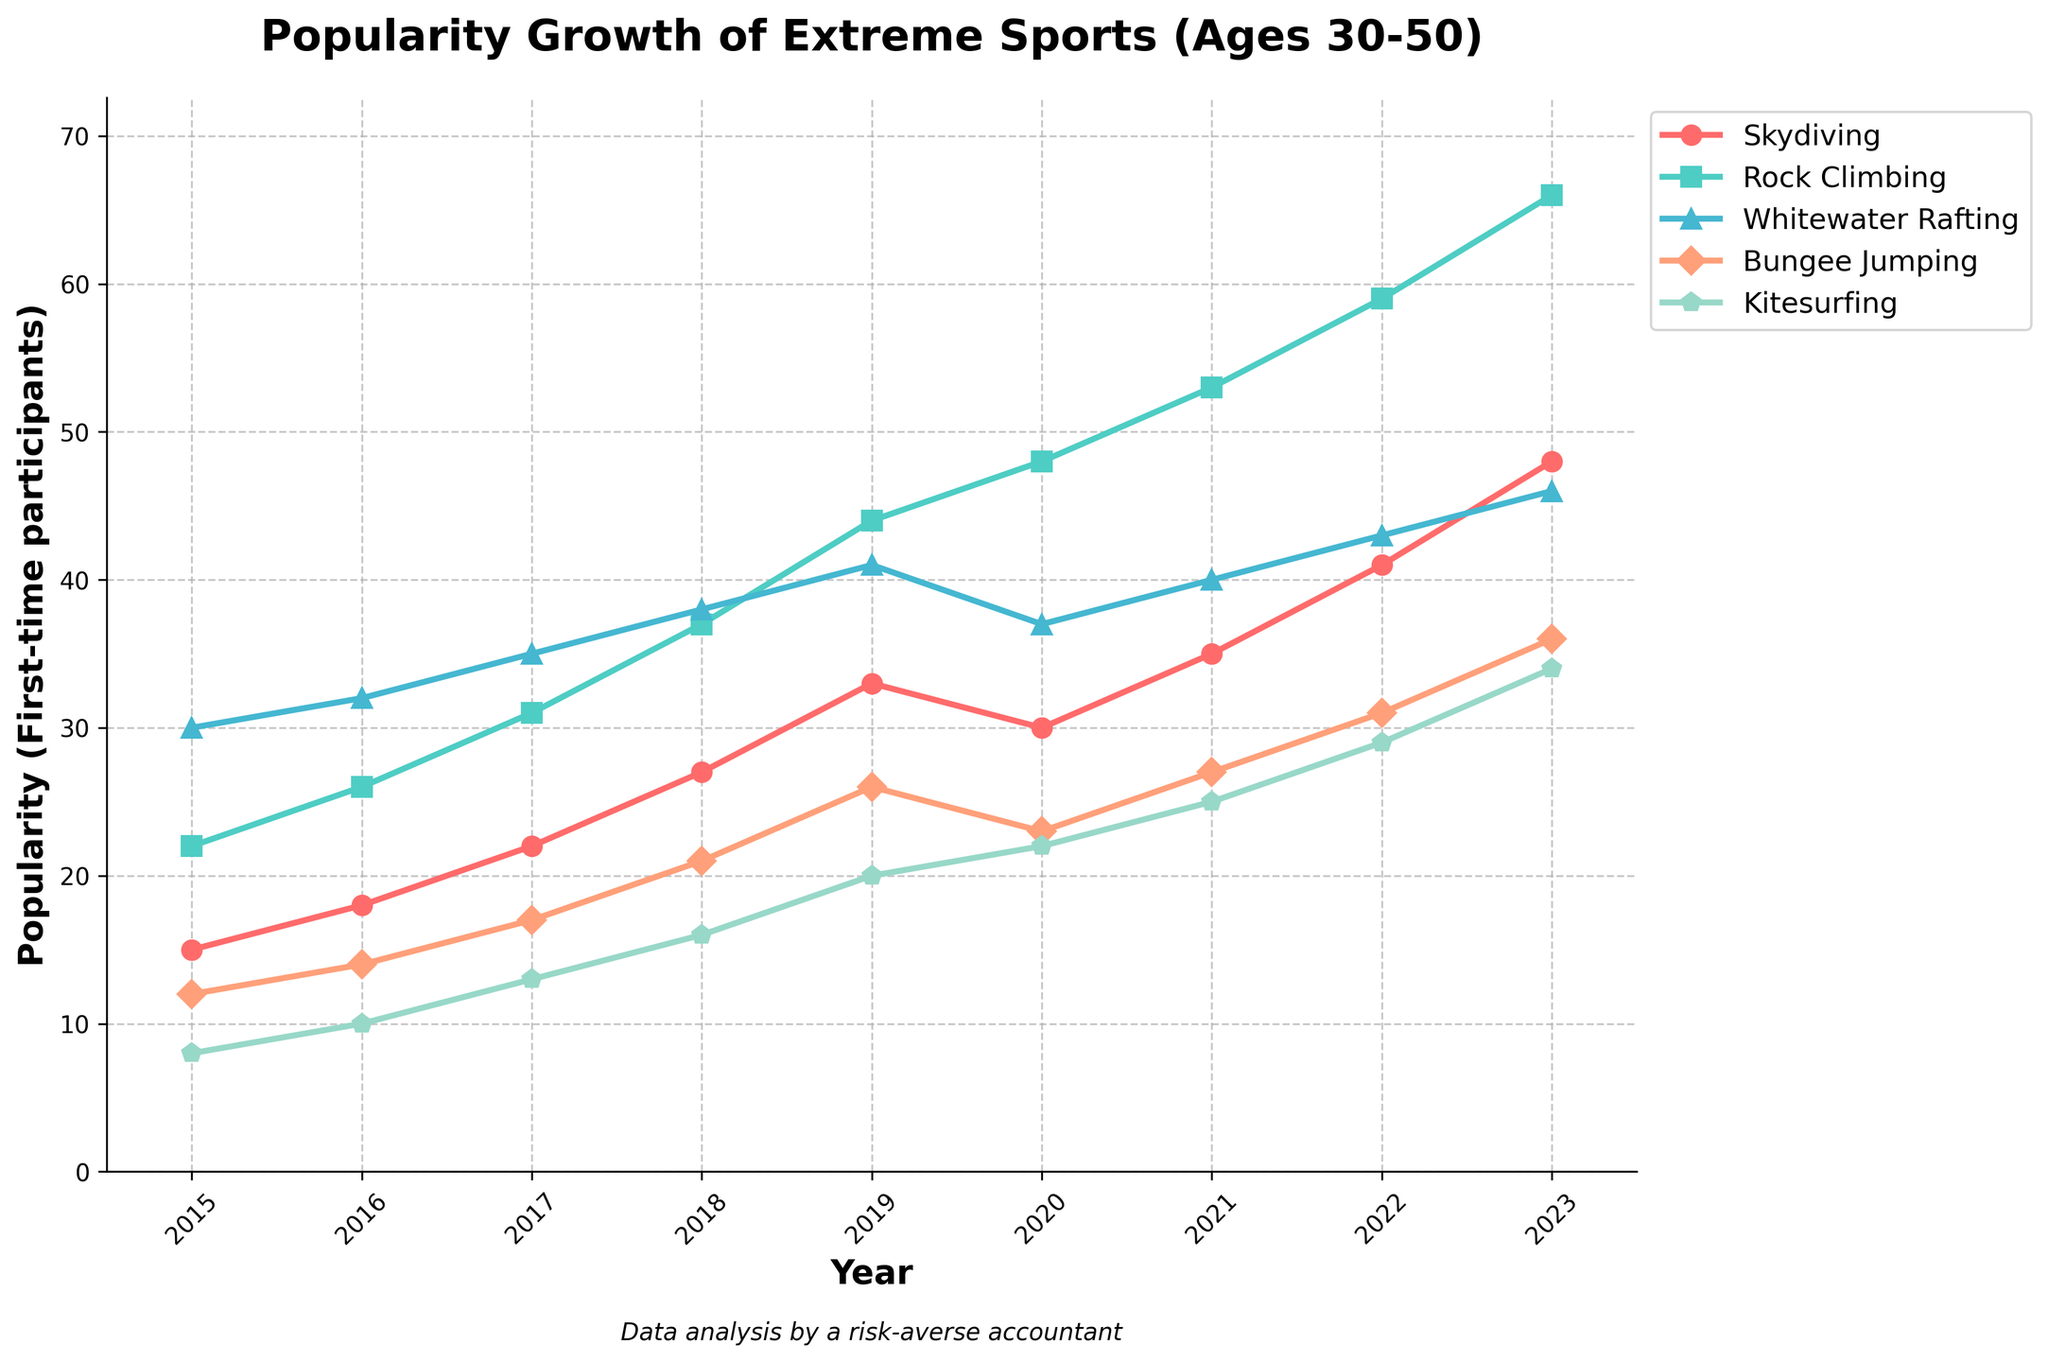What is the trend for skydiving's popularity between 2015 and 2023? The chart shows that the popularity of skydiving among first-time participants aged 30-50 increased steadily from 15 in 2015 to 48 in 2023. The values consistently rise each year.
Answer: Steadily increasing Which sport had the highest popularity in 2023? By looking at the chart, you can see that Rock Climbing has the highest number of first-time participants in 2023, reaching 66.
Answer: Rock Climbing During which year did whitewater rafting see its highest number of first-time participants? The chart indicates that the highest number of first-time participants for Whitewater Rafting is 46, which occurs in the year 2023.
Answer: 2023 Compare the popularity of bungee jumping and kitesurfing in 2019. Which one was more popular? The chart shows that in 2019, bungee jumping had 26 first-time participants while kitesurfing had 20. Thus, bungee jumping was more popular.
Answer: Bungee Jumping What was the total number of first-time participants for Rock Climbing in 2015 and 2023 combined? By adding the number of first-time participants for Rock Climbing in 2015 (22) and 2023 (66), the total is 22 + 66 = 88.
Answer: 88 What is the average number of first-time participants for kitesurfing from 2015 to 2023? Adding up all the values for kitesurfing for each year (8, 10, 13, 16, 20, 22, 25, 29, 34) and then dividing by the number of years (9), we get (8 + 10 + 13 + 16 + 20 + 22 + 25 + 29 + 34) / 9 = 177 / 9 = 19.67.
Answer: 19.67 Which sport saw the largest increase in first-time participants from 2015 to 2023? By subtracting the 2015 value from the 2023 value for each sport and comparing the differences, Rock Climbing increased the most from 22 to 66 (difference of 44).
Answer: Rock Climbing In which year did skydiving and whitewater rafting have nearly the same number of first-time participants? By looking at the chart, in 2020, skydiving had 30 first-time participants while whitewater rafting had 37. The values are relatively close but not exact. The closest they come to equal is in 2020.
Answer: 2020 Which color represents skydiving on the chart? By referring to the chart, the color representing skydiving is red.
Answer: Red 